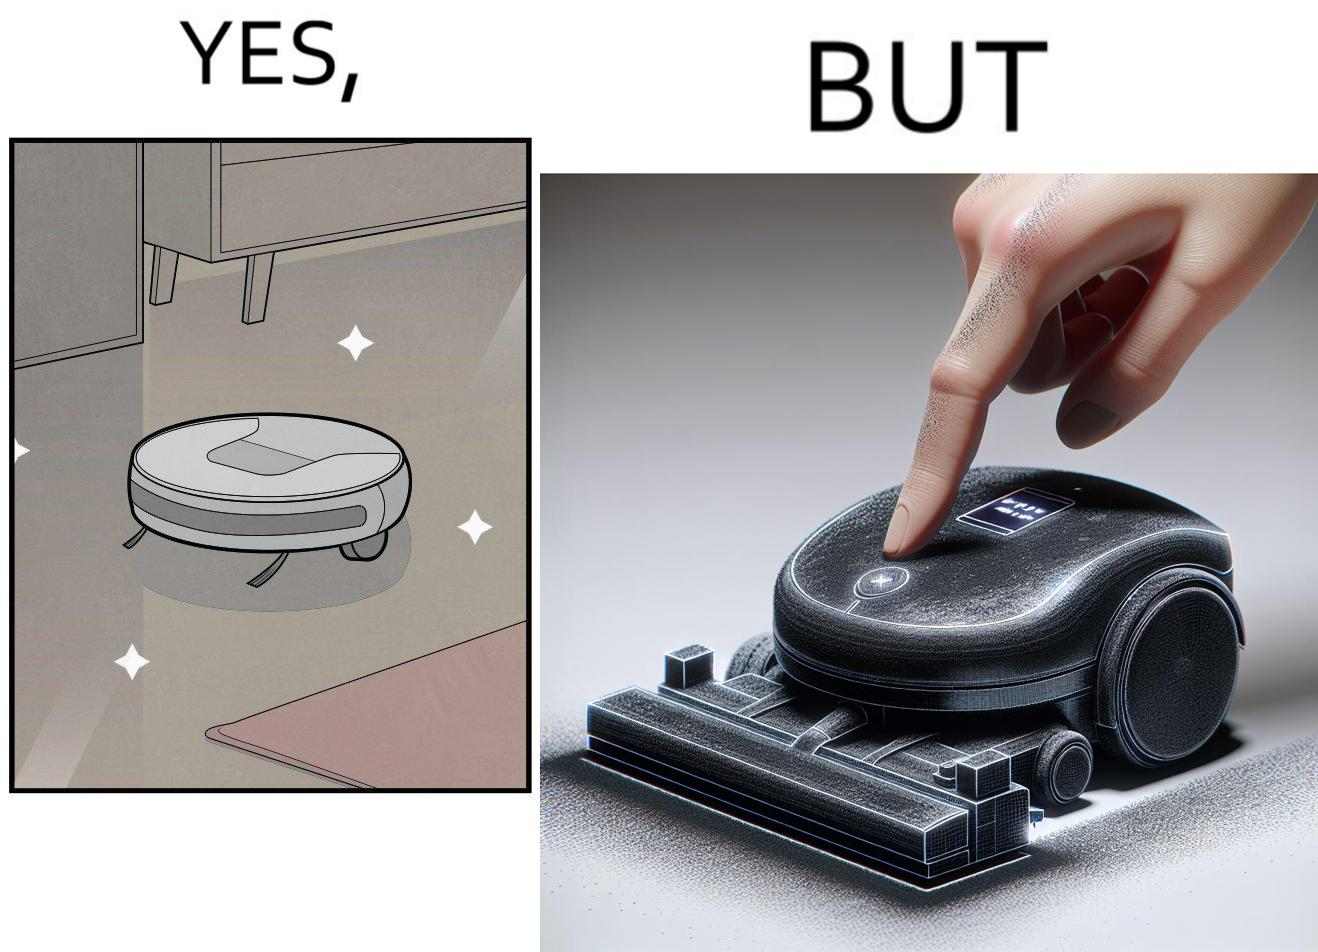What is the satirical meaning behind this image? This is funny, because the machine while doing its job cleans everything but ends up being dirty itself. 